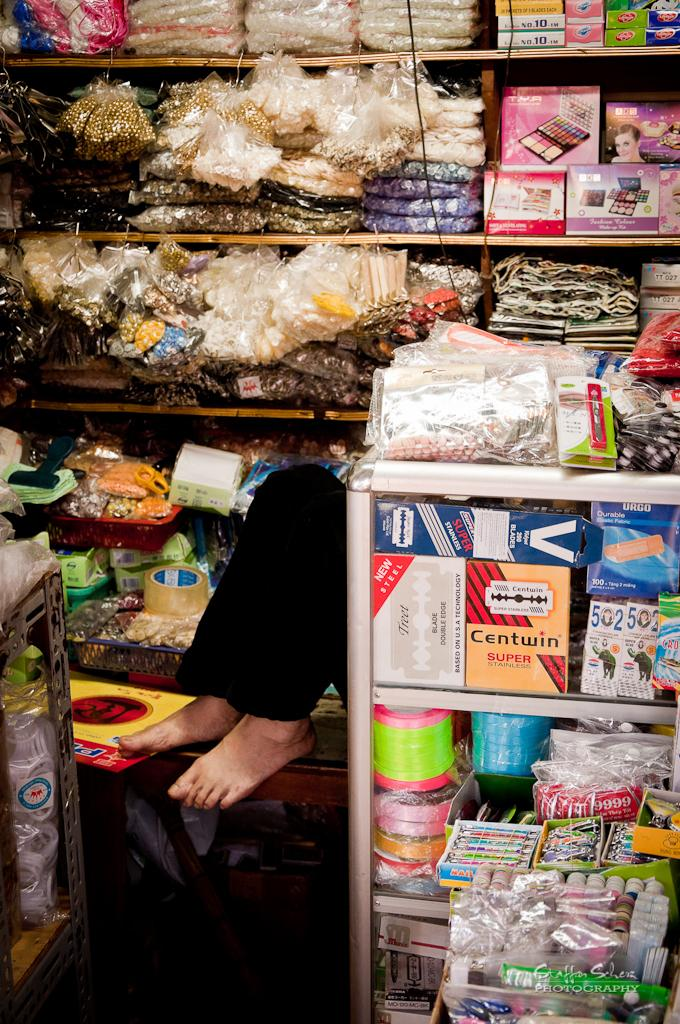Provide a one-sentence caption for the provided image. Store selling many items including one named "Centwin". 